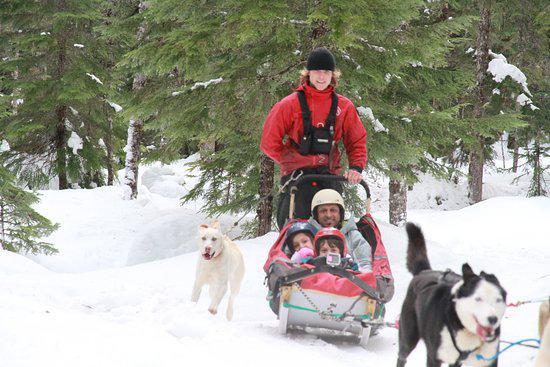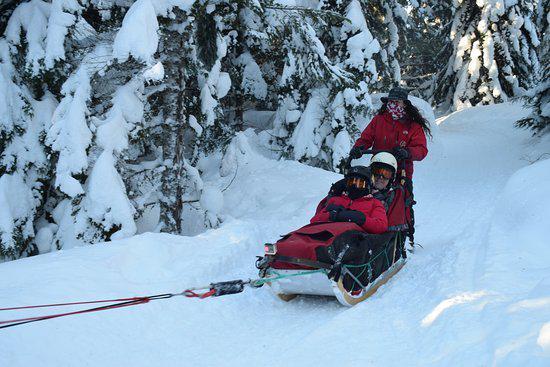The first image is the image on the left, the second image is the image on the right. For the images shown, is this caption "there is a dog sled team pulling a sled with one person standing and 3 people inside the sled" true? Answer yes or no. Yes. The first image is the image on the left, the second image is the image on the right. Examine the images to the left and right. Is the description "The man standing behind the sled in the image on the left is wearing a red jacket." accurate? Answer yes or no. Yes. 